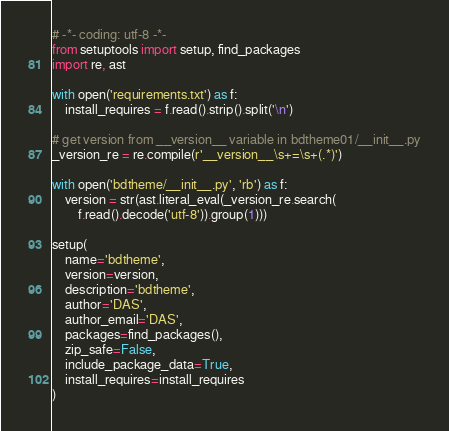Convert code to text. <code><loc_0><loc_0><loc_500><loc_500><_Python_># -*- coding: utf-8 -*-
from setuptools import setup, find_packages
import re, ast

with open('requirements.txt') as f:
	install_requires = f.read().strip().split('\n')

# get version from __version__ variable in bdtheme01/__init__.py
_version_re = re.compile(r'__version__\s+=\s+(.*)')

with open('bdtheme/__init__.py', 'rb') as f:
	version = str(ast.literal_eval(_version_re.search(
		f.read().decode('utf-8')).group(1)))

setup(
	name='bdtheme',
	version=version,
	description='bdtheme',
	author='DAS',
	author_email='DAS',
	packages=find_packages(),
	zip_safe=False,
	include_package_data=True,
	install_requires=install_requires
)
</code> 